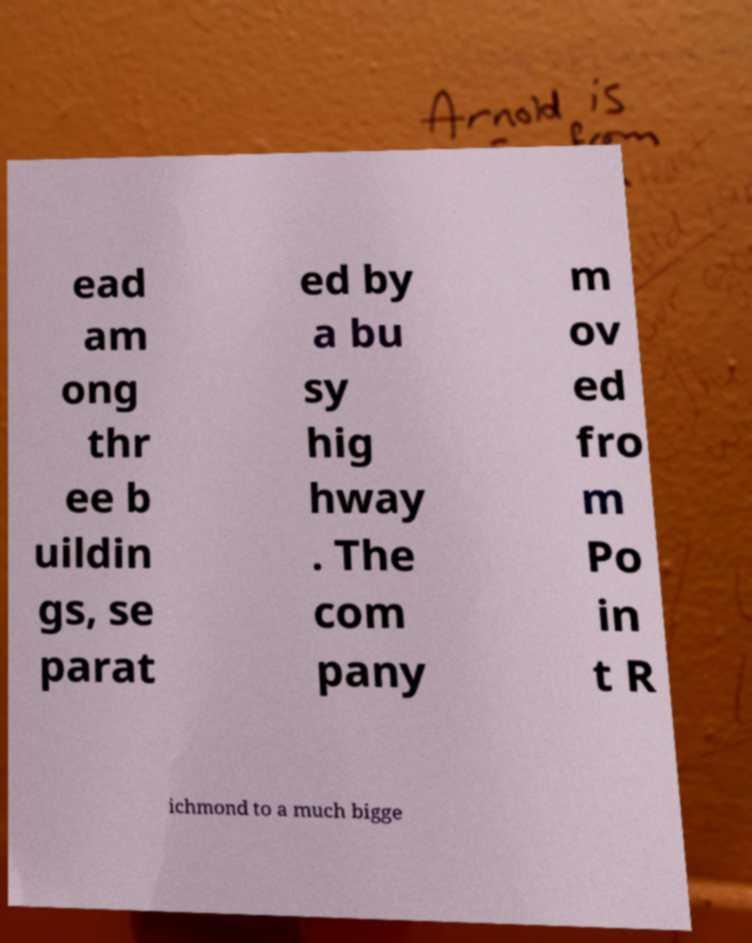Could you assist in decoding the text presented in this image and type it out clearly? ead am ong thr ee b uildin gs, se parat ed by a bu sy hig hway . The com pany m ov ed fro m Po in t R ichmond to a much bigge 